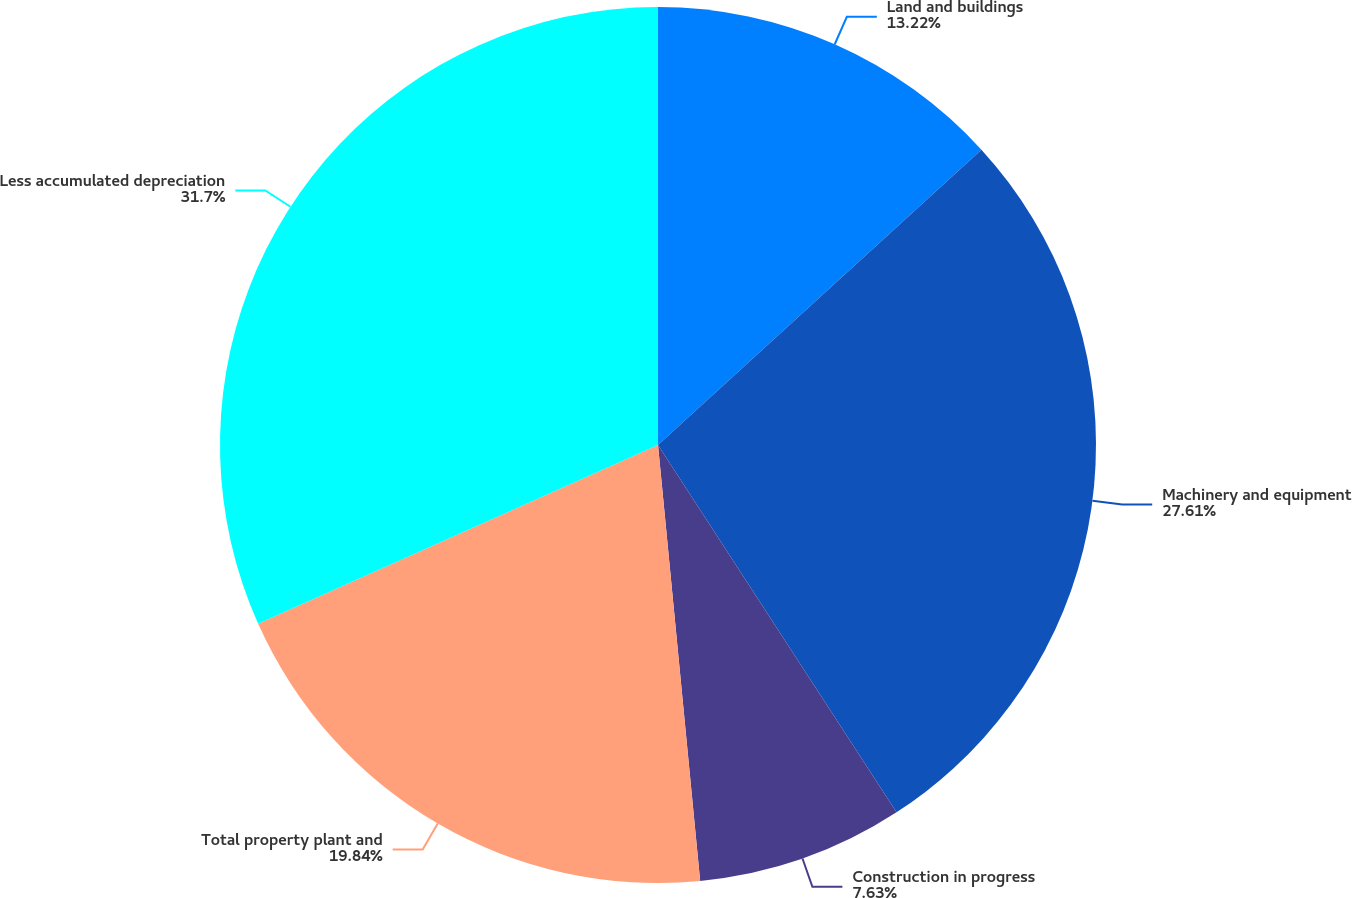<chart> <loc_0><loc_0><loc_500><loc_500><pie_chart><fcel>Land and buildings<fcel>Machinery and equipment<fcel>Construction in progress<fcel>Total property plant and<fcel>Less accumulated depreciation<nl><fcel>13.22%<fcel>27.61%<fcel>7.63%<fcel>19.84%<fcel>31.69%<nl></chart> 